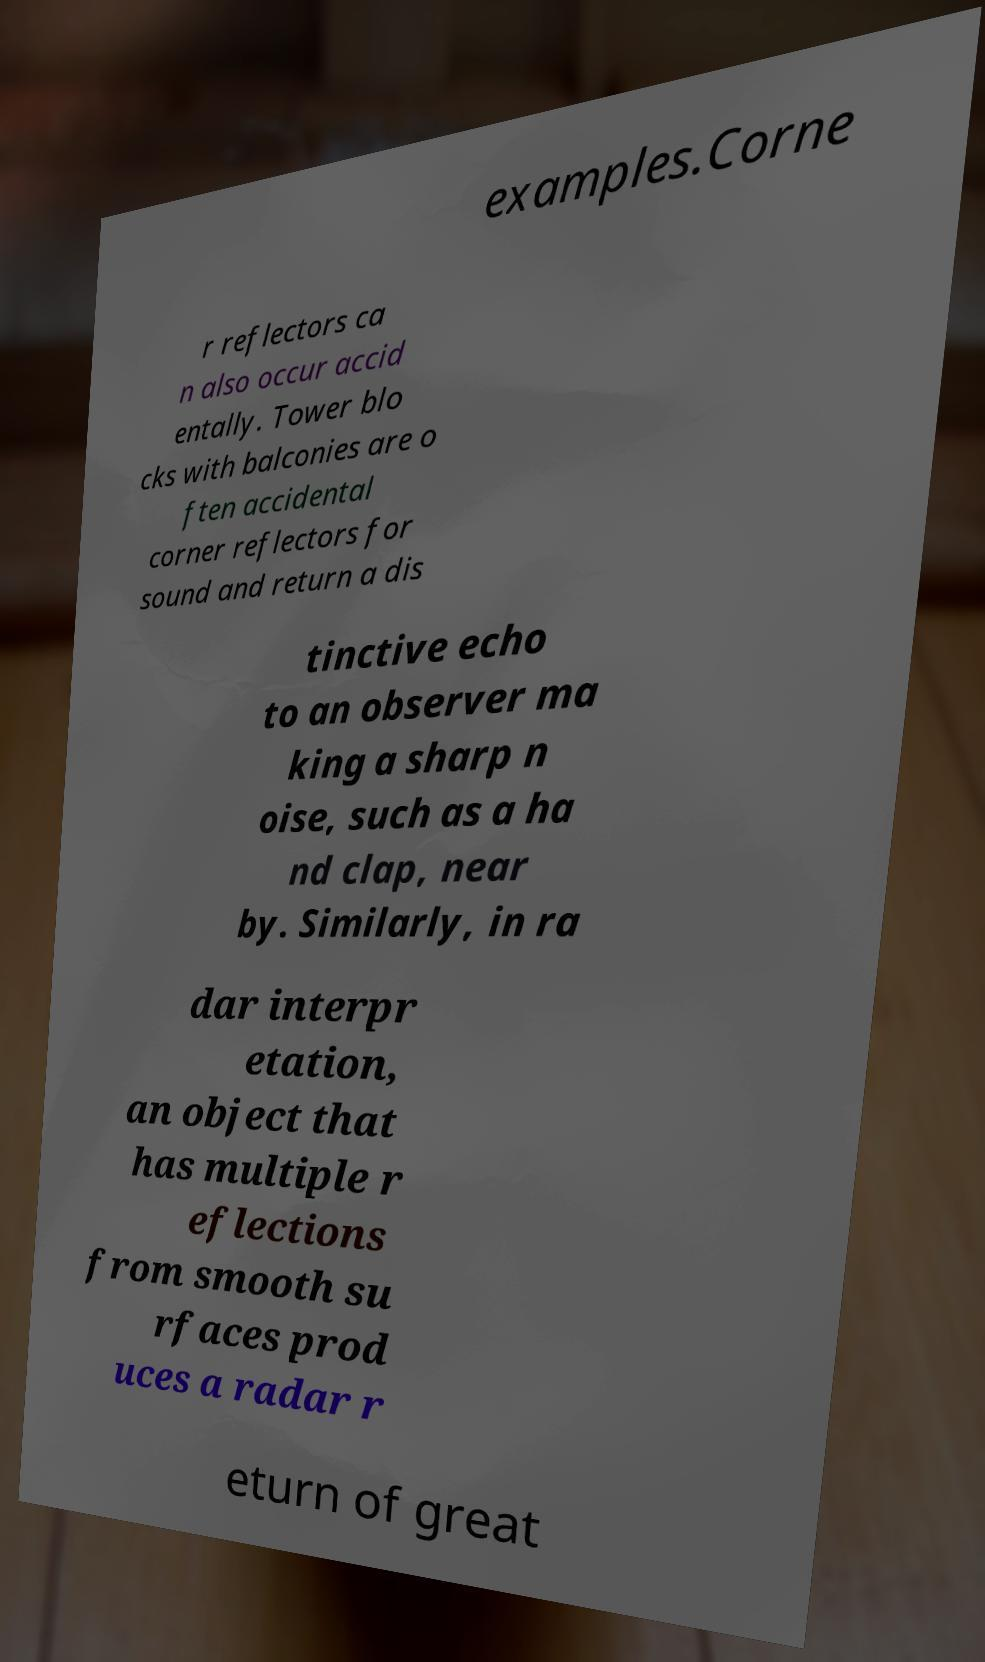Could you assist in decoding the text presented in this image and type it out clearly? examples.Corne r reflectors ca n also occur accid entally. Tower blo cks with balconies are o ften accidental corner reflectors for sound and return a dis tinctive echo to an observer ma king a sharp n oise, such as a ha nd clap, near by. Similarly, in ra dar interpr etation, an object that has multiple r eflections from smooth su rfaces prod uces a radar r eturn of great 